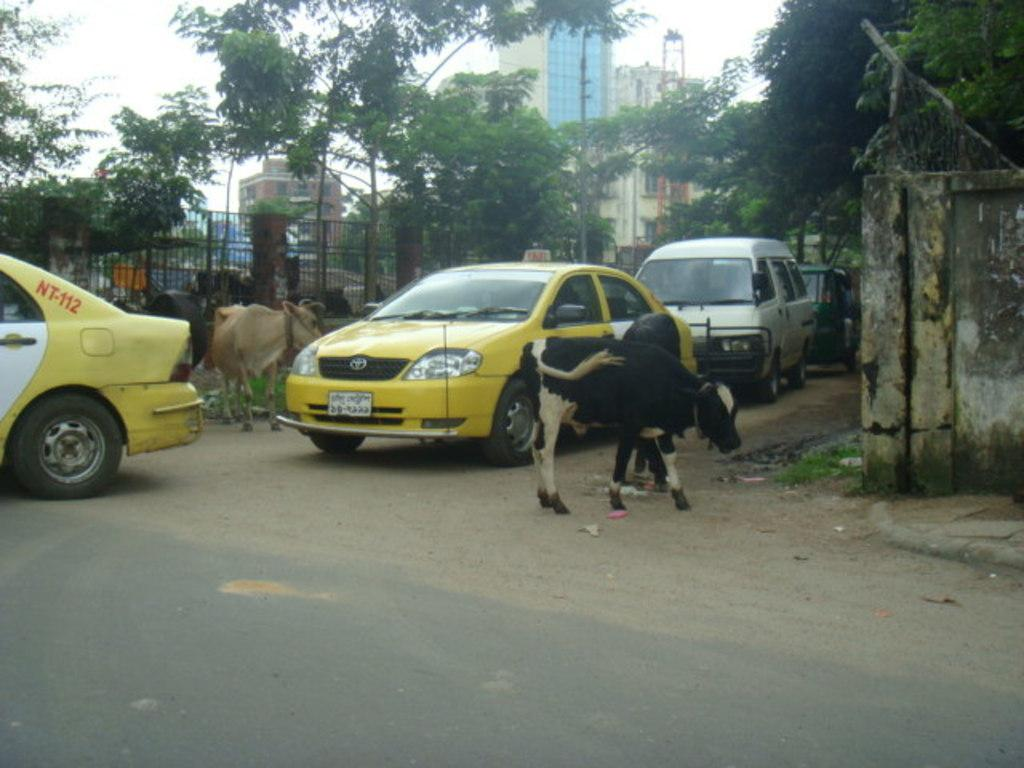<image>
Share a concise interpretation of the image provided. A couple of cabs, the one in front says NT-112. 